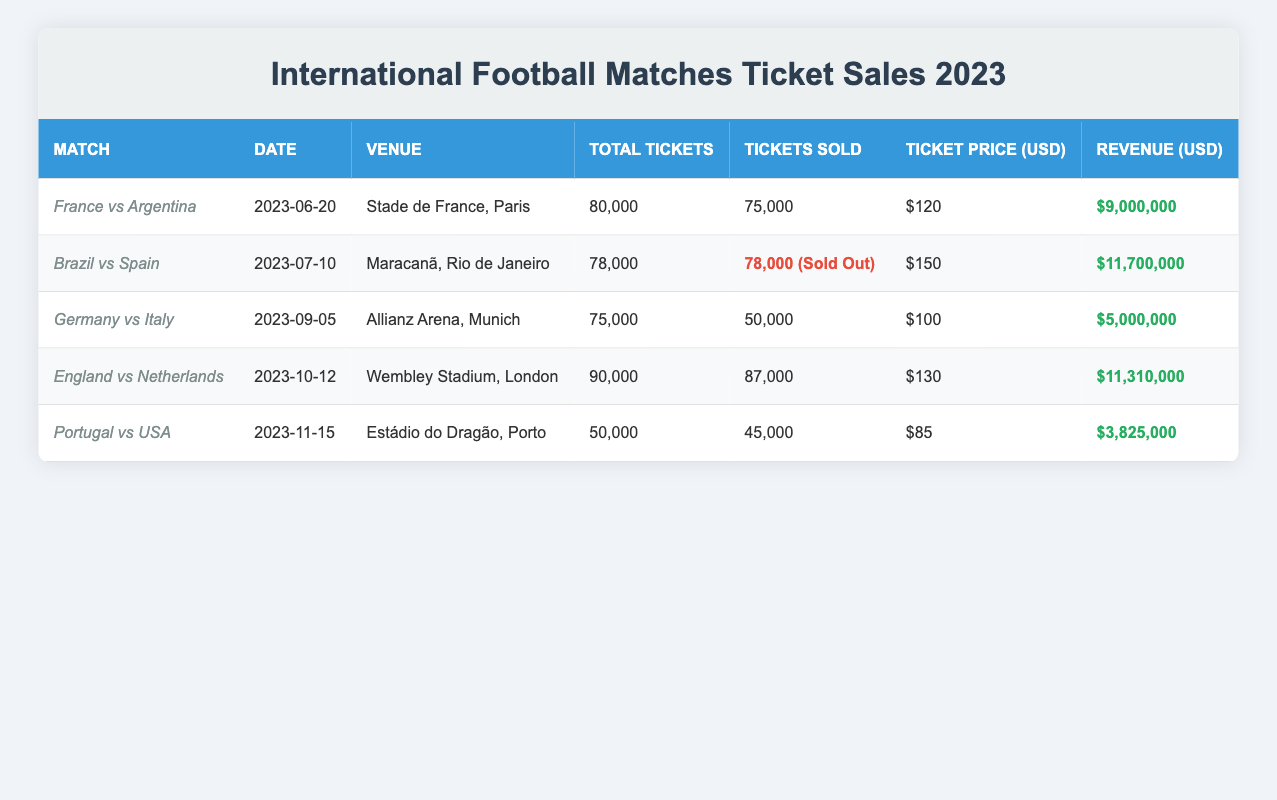What is the highest ticket price among the matches? The ticket prices for the matches are $120, $150, $100, $130, and $85. The highest among these is $150 for the match between Brazil and Spain.
Answer: $150 Which match had the most tickets sold? The match between Brazil and Spain sold 78,000 tickets, which is the highest number of tickets sold when comparing with the other matches.
Answer: 78,000 What is the total revenue generated from all matches? To find the total revenue, we sum the revenues from each match: 9,000,000 + 11,700,000 + 5,000,000 + 11,310,000 + 3,825,000 = 41,835,000.
Answer: 41,835,000 Did England vs Netherlands sell more tickets than Germany vs Italy? England vs Netherlands sold 87,000 tickets while Germany vs Italy sold 50,000 tickets. Since 87,000 is greater than 50,000, the statement is true.
Answer: Yes What was the average number of tickets sold across all matches? The total number of tickets sold is 75,000 + 78,000 + 50,000 + 87,000 + 45,000 = 335,000. There are 5 matches, so the average is 335,000 / 5 = 67,000.
Answer: 67,000 What percentage of tickets were sold for the match between France and Argentina? The match had 75,000 tickets sold out of 80,000 total tickets. Therefore, the percentage is (75,000 / 80,000) * 100 = 93.75%.
Answer: 93.75% Is there a match that is sold out? The match between Brazil and Spain sold all 78,000 tickets, meaning it is sold out.
Answer: Yes How much revenue did Portugal vs USA generate? The revenue for the match between Portugal and USA is listed as $3,825,000. There is no need for further calculations.
Answer: $3,825,000 Which match had the least total tickets available? Portugal vs USA had the least with a total of 50,000 tickets, in comparison to other matches that had more.
Answer: 50,000 